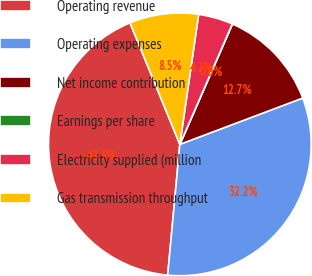<chart> <loc_0><loc_0><loc_500><loc_500><pie_chart><fcel>Operating revenue<fcel>Operating expenses<fcel>Net income contribution<fcel>Earnings per share<fcel>Electricity supplied (million<fcel>Gas transmission throughput<nl><fcel>42.33%<fcel>32.21%<fcel>12.71%<fcel>0.02%<fcel>4.25%<fcel>8.48%<nl></chart> 